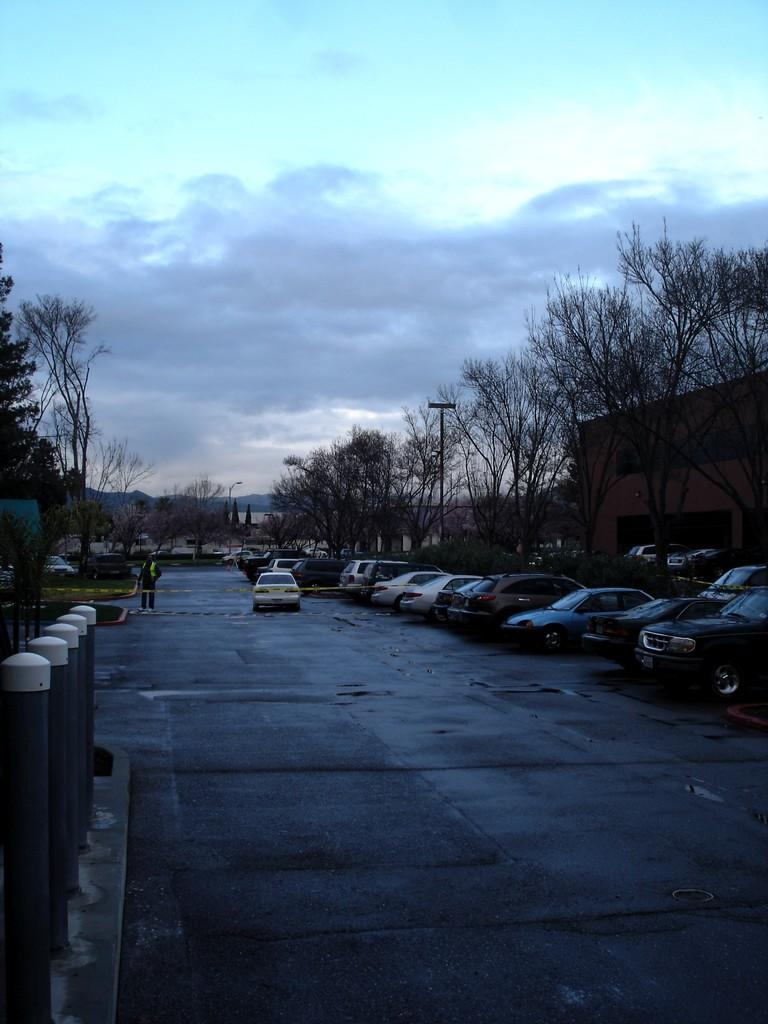What type of vegetation can be seen in the image? There are trees in the image. What can be seen parked on the side of the road in the image? There are cars parked in the image. What is the car doing on the road in the image? A car is moving on the road in the image. What is the human doing in the image? There is a human walking in the image. What type of structure is visible in the image? There is a building in the image. How would you describe the sky in the image? The sky is blue and cloudy in the image. What can be seen on the side of the road in the image? There are poles on the side of the road in the image. Where are the sheep grazing in the image? There are no sheep present in the image. What type of cake is being served at the party in the image? There is no party or cake present in the image. How many fish can be seen swimming in the river in the image? There is no river or fish present in the image. 